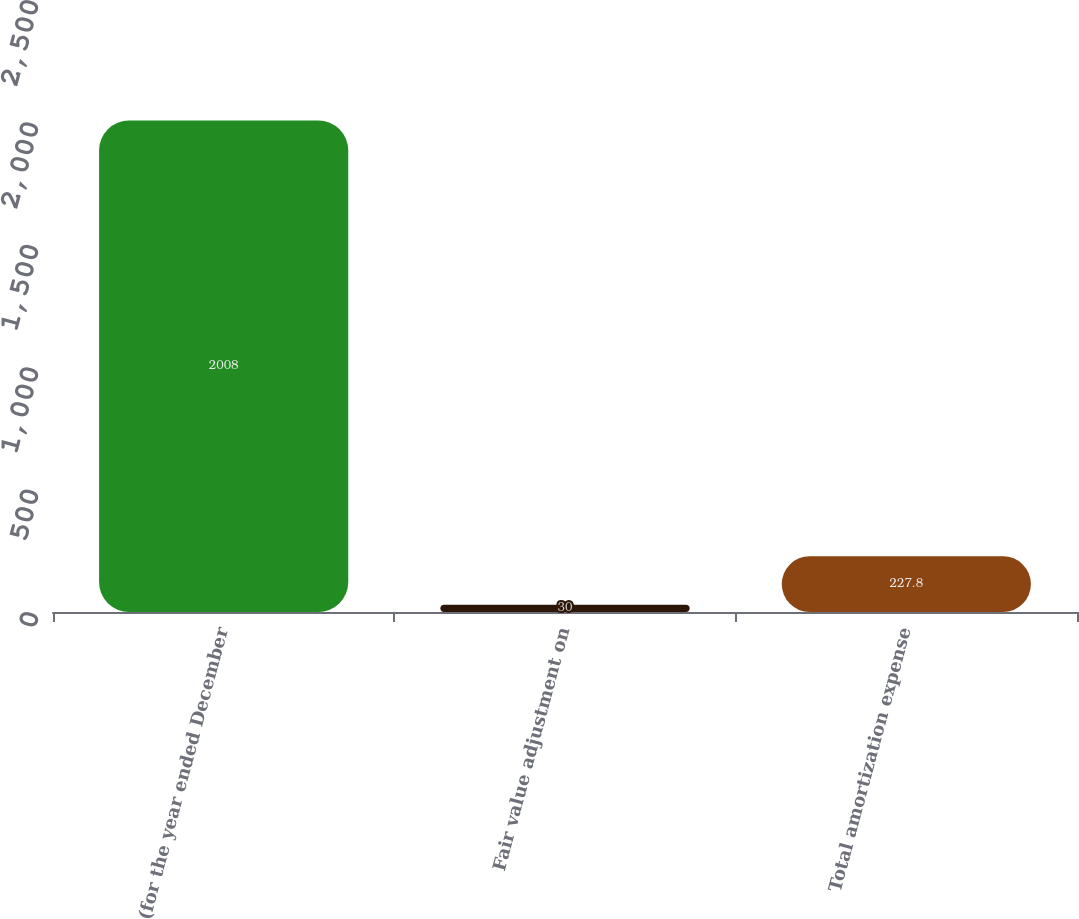<chart> <loc_0><loc_0><loc_500><loc_500><bar_chart><fcel>(for the year ended December<fcel>Fair value adjustment on<fcel>Total amortization expense<nl><fcel>2008<fcel>30<fcel>227.8<nl></chart> 